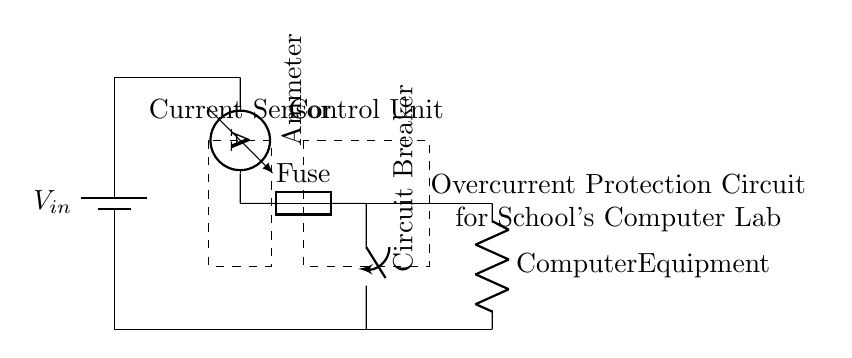What type of protection device is used in this circuit? The circuit includes a fuse, which is a protective device designed to interrupt current flow when it exceeds a predetermined level.
Answer: Fuse What does the current sensor monitor? The current sensor monitors the amount of current flowing through the circuit and detects overcurrent conditions.
Answer: Current What is located in the dashed rectangle at the top of the diagram? The dashed rectangle represents the current sensor, which is used to monitor the electrical current flowing in the circuit.
Answer: Current Sensor Which component acts as the main protective mechanism? The circuit breaker serves as the main protective mechanism, which will open the circuit when overcurrent is detected to prevent damage.
Answer: Circuit Breaker What load is connected to the circuit? The load mentioned in the circuit is identified as the computer equipment, which is powered by the circuit.
Answer: Computer Equipment How does the fuse function in the context of this circuit? The fuse protects the circuit by melting and breaking the circuit connection when the current exceeds its rated capacity.
Answer: Melting What is the purpose of the control unit? The control unit manages the signals from the current sensor and operates the circuit breaker to provide overcurrent protection.
Answer: Manage signals 